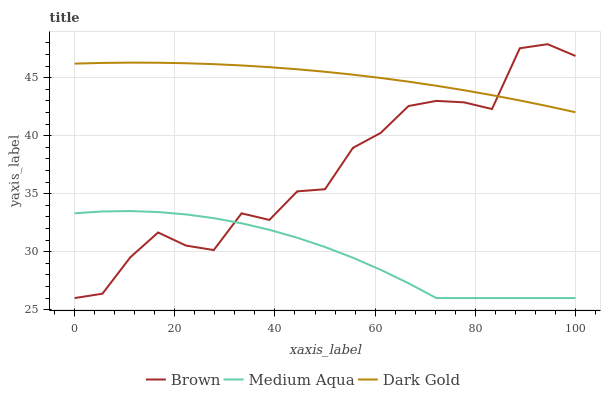Does Medium Aqua have the minimum area under the curve?
Answer yes or no. Yes. Does Dark Gold have the maximum area under the curve?
Answer yes or no. Yes. Does Dark Gold have the minimum area under the curve?
Answer yes or no. No. Does Medium Aqua have the maximum area under the curve?
Answer yes or no. No. Is Dark Gold the smoothest?
Answer yes or no. Yes. Is Brown the roughest?
Answer yes or no. Yes. Is Medium Aqua the smoothest?
Answer yes or no. No. Is Medium Aqua the roughest?
Answer yes or no. No. Does Brown have the lowest value?
Answer yes or no. Yes. Does Dark Gold have the lowest value?
Answer yes or no. No. Does Brown have the highest value?
Answer yes or no. Yes. Does Dark Gold have the highest value?
Answer yes or no. No. Is Medium Aqua less than Dark Gold?
Answer yes or no. Yes. Is Dark Gold greater than Medium Aqua?
Answer yes or no. Yes. Does Brown intersect Medium Aqua?
Answer yes or no. Yes. Is Brown less than Medium Aqua?
Answer yes or no. No. Is Brown greater than Medium Aqua?
Answer yes or no. No. Does Medium Aqua intersect Dark Gold?
Answer yes or no. No. 